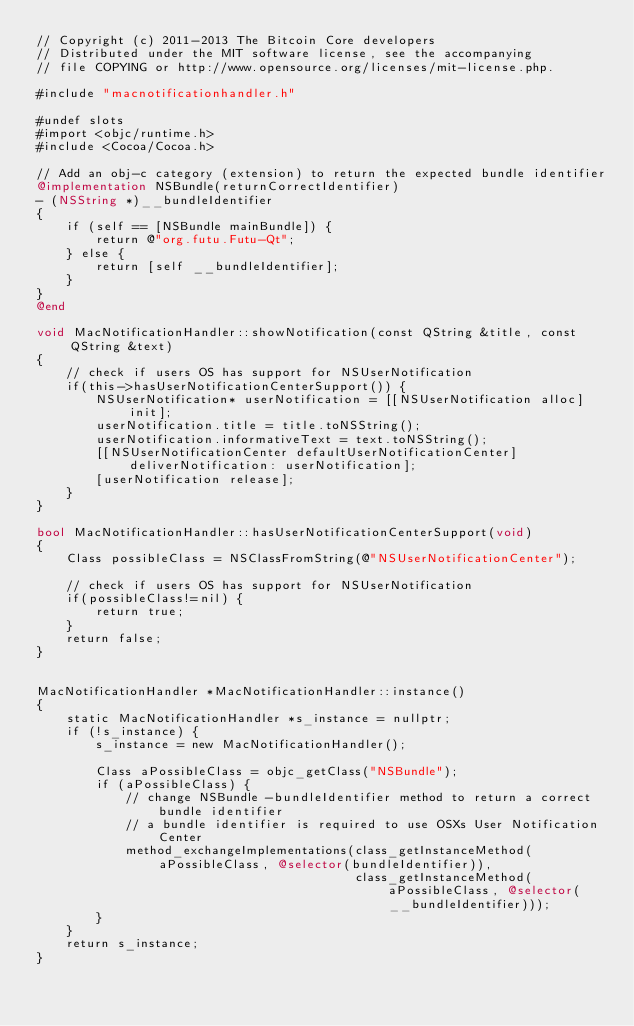Convert code to text. <code><loc_0><loc_0><loc_500><loc_500><_ObjectiveC_>// Copyright (c) 2011-2013 The Bitcoin Core developers
// Distributed under the MIT software license, see the accompanying
// file COPYING or http://www.opensource.org/licenses/mit-license.php.

#include "macnotificationhandler.h"

#undef slots
#import <objc/runtime.h>
#include <Cocoa/Cocoa.h>

// Add an obj-c category (extension) to return the expected bundle identifier
@implementation NSBundle(returnCorrectIdentifier)
- (NSString *)__bundleIdentifier
{
    if (self == [NSBundle mainBundle]) {
        return @"org.futu.Futu-Qt";
    } else {
        return [self __bundleIdentifier];
    }
}
@end

void MacNotificationHandler::showNotification(const QString &title, const QString &text)
{
    // check if users OS has support for NSUserNotification
    if(this->hasUserNotificationCenterSupport()) {
        NSUserNotification* userNotification = [[NSUserNotification alloc] init];
        userNotification.title = title.toNSString();
        userNotification.informativeText = text.toNSString();
        [[NSUserNotificationCenter defaultUserNotificationCenter] deliverNotification: userNotification];
        [userNotification release];
    }
}

bool MacNotificationHandler::hasUserNotificationCenterSupport(void)
{
    Class possibleClass = NSClassFromString(@"NSUserNotificationCenter");

    // check if users OS has support for NSUserNotification
    if(possibleClass!=nil) {
        return true;
    }
    return false;
}


MacNotificationHandler *MacNotificationHandler::instance()
{
    static MacNotificationHandler *s_instance = nullptr;
    if (!s_instance) {
        s_instance = new MacNotificationHandler();

        Class aPossibleClass = objc_getClass("NSBundle");
        if (aPossibleClass) {
            // change NSBundle -bundleIdentifier method to return a correct bundle identifier
            // a bundle identifier is required to use OSXs User Notification Center
            method_exchangeImplementations(class_getInstanceMethod(aPossibleClass, @selector(bundleIdentifier)),
                                           class_getInstanceMethod(aPossibleClass, @selector(__bundleIdentifier)));
        }
    }
    return s_instance;
}
</code> 